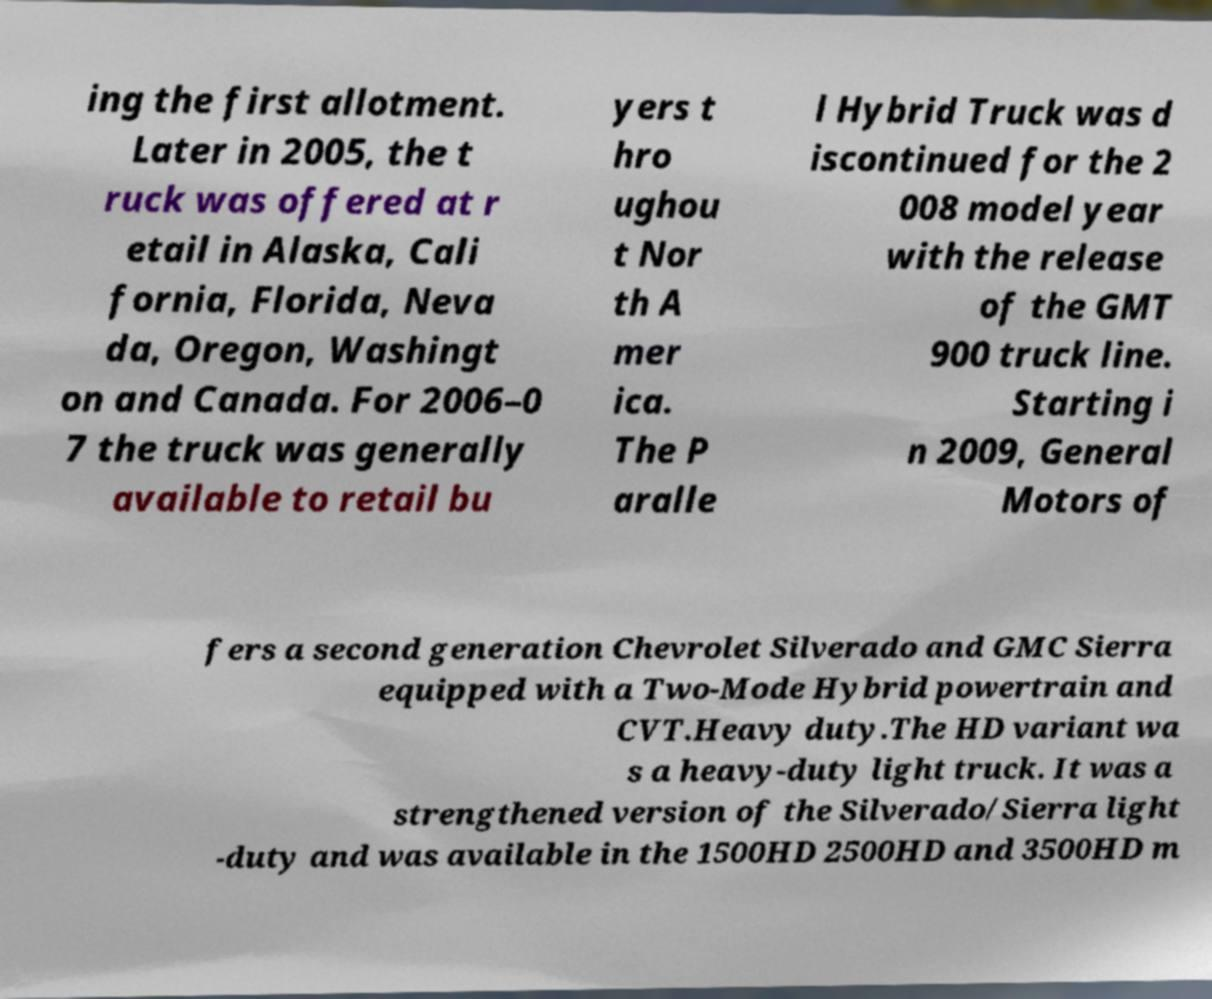Could you assist in decoding the text presented in this image and type it out clearly? ing the first allotment. Later in 2005, the t ruck was offered at r etail in Alaska, Cali fornia, Florida, Neva da, Oregon, Washingt on and Canada. For 2006–0 7 the truck was generally available to retail bu yers t hro ughou t Nor th A mer ica. The P aralle l Hybrid Truck was d iscontinued for the 2 008 model year with the release of the GMT 900 truck line. Starting i n 2009, General Motors of fers a second generation Chevrolet Silverado and GMC Sierra equipped with a Two-Mode Hybrid powertrain and CVT.Heavy duty.The HD variant wa s a heavy-duty light truck. It was a strengthened version of the Silverado/Sierra light -duty and was available in the 1500HD 2500HD and 3500HD m 